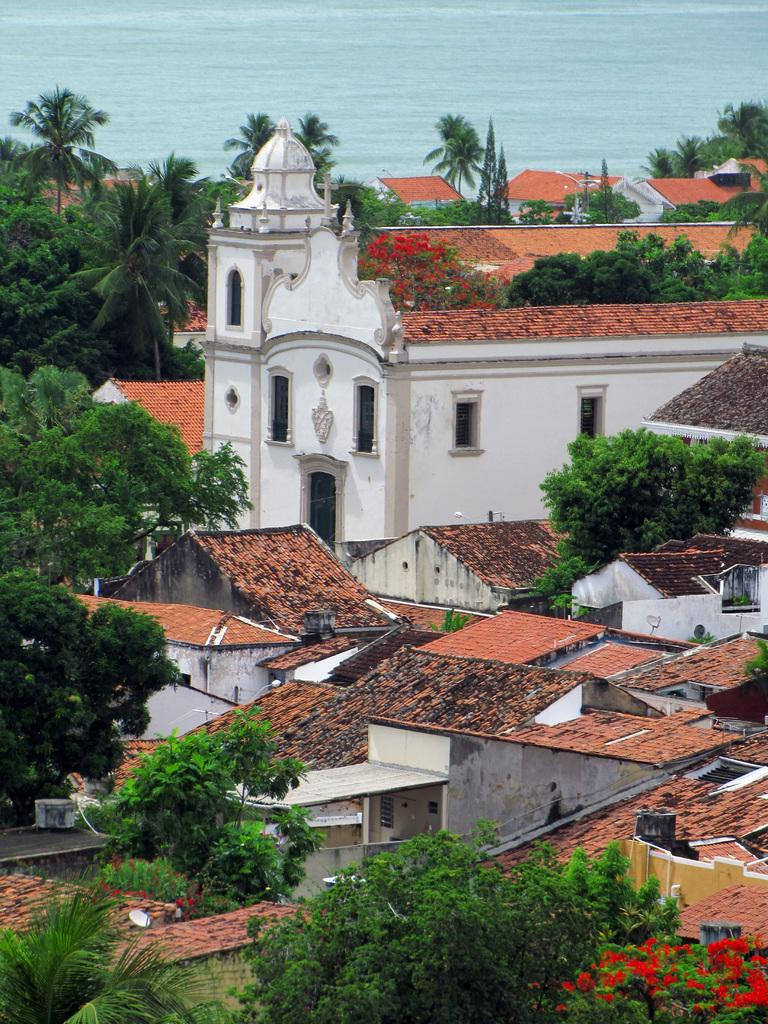What type of natural elements can be seen in the image? There are trees in the image. What type of man-made structures are present in the image? There are houses in the image. What can be seen in the background of the image? There is water visible in the background of the image. What songs are being sung by the trees in the image? There are no songs being sung by the trees in the image, as trees do not have the ability to sing. Can you tell me the distance between the houses and the water in the image? The distance between the houses and the water cannot be determined from the image alone, as there is no scale or reference point provided. 